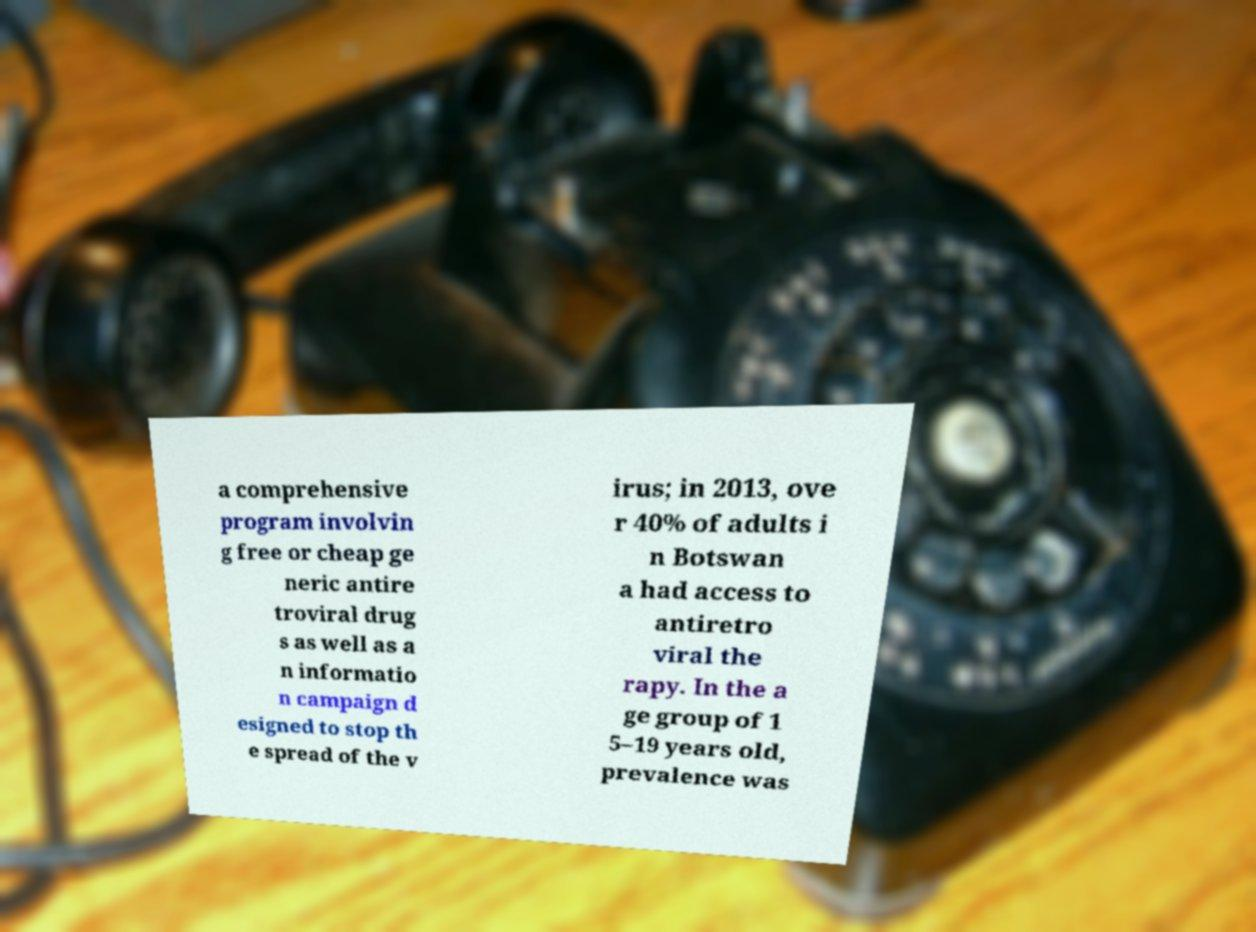For documentation purposes, I need the text within this image transcribed. Could you provide that? a comprehensive program involvin g free or cheap ge neric antire troviral drug s as well as a n informatio n campaign d esigned to stop th e spread of the v irus; in 2013, ove r 40% of adults i n Botswan a had access to antiretro viral the rapy. In the a ge group of 1 5–19 years old, prevalence was 